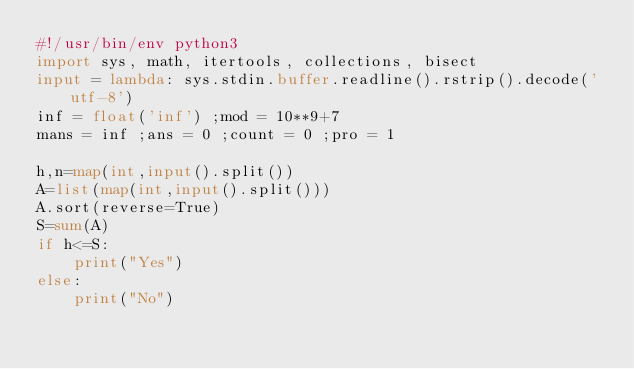Convert code to text. <code><loc_0><loc_0><loc_500><loc_500><_Python_>#!/usr/bin/env python3
import sys, math, itertools, collections, bisect
input = lambda: sys.stdin.buffer.readline().rstrip().decode('utf-8')
inf = float('inf') ;mod = 10**9+7
mans = inf ;ans = 0 ;count = 0 ;pro = 1

h,n=map(int,input().split())
A=list(map(int,input().split()))
A.sort(reverse=True)
S=sum(A)
if h<=S:
    print("Yes")
else:
    print("No")</code> 